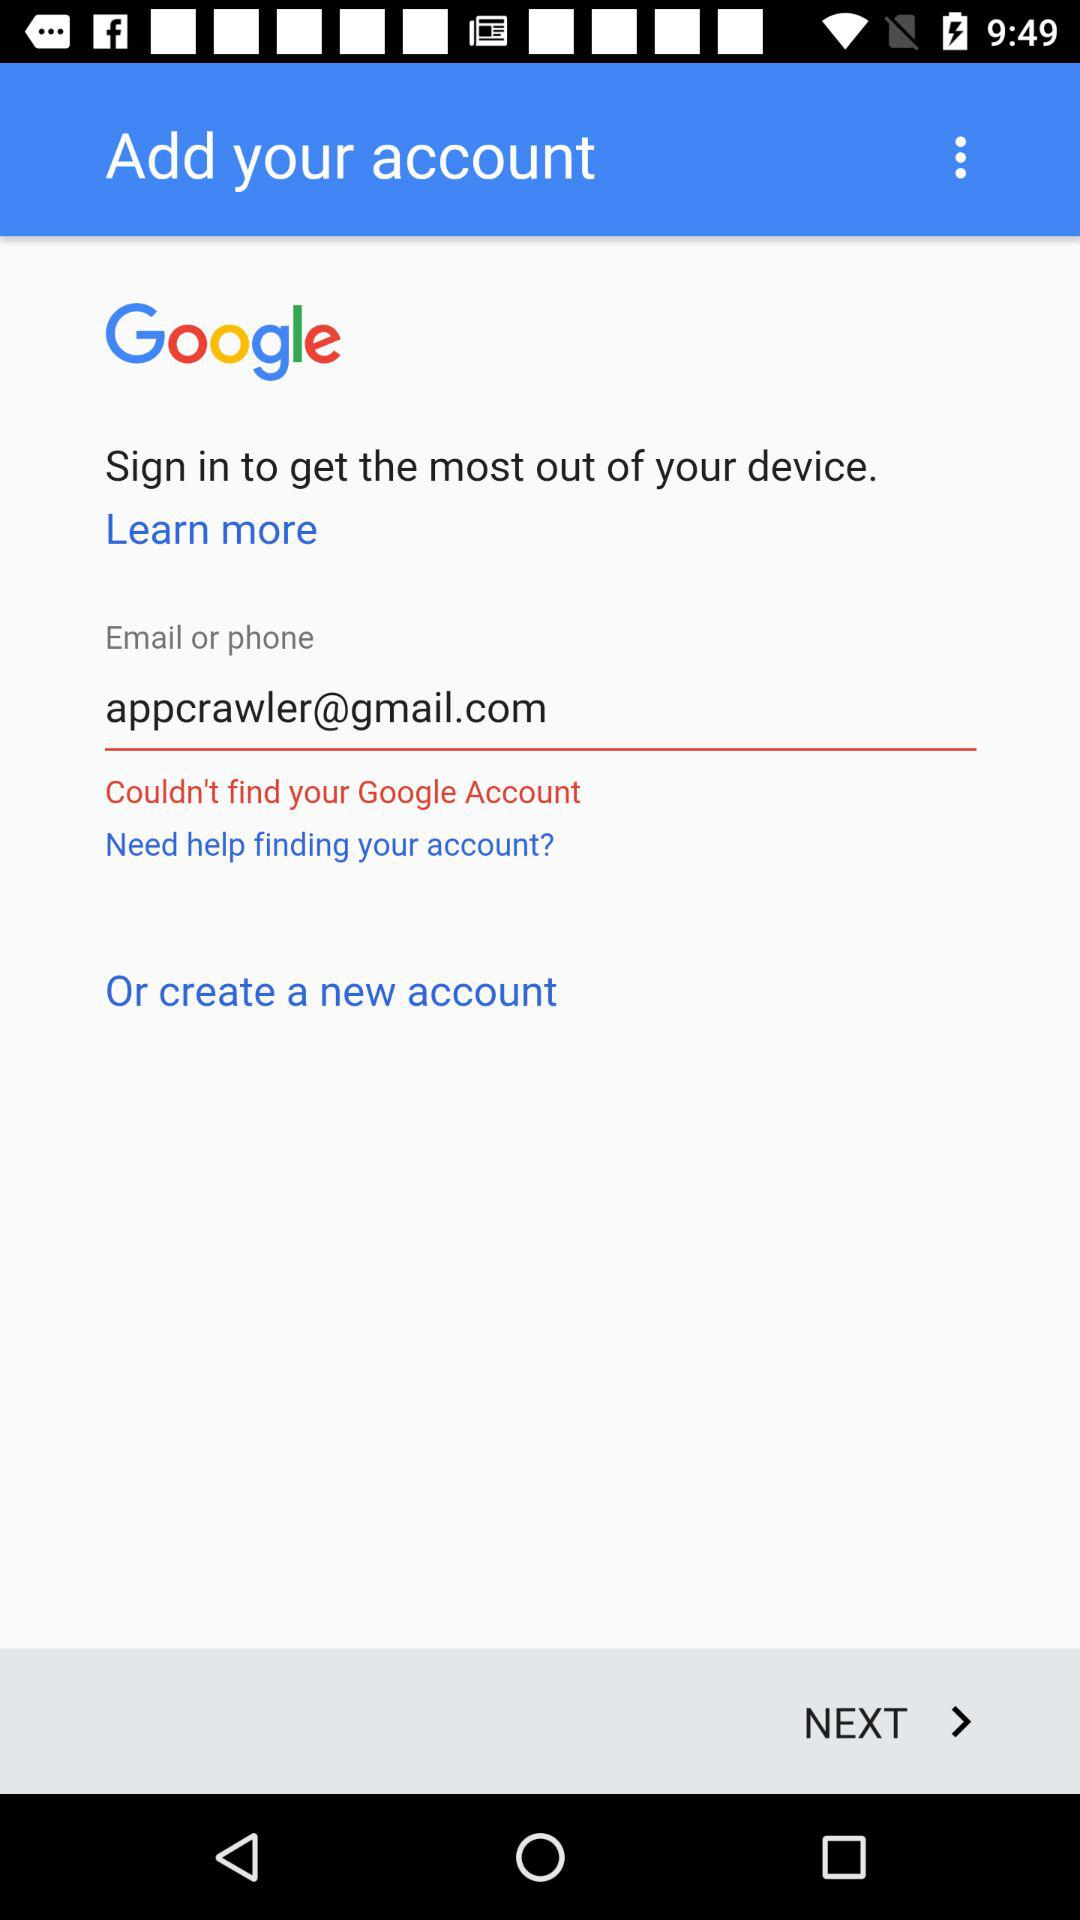What is the email address of the user? The email address is "appcrawler@gmail.com". 